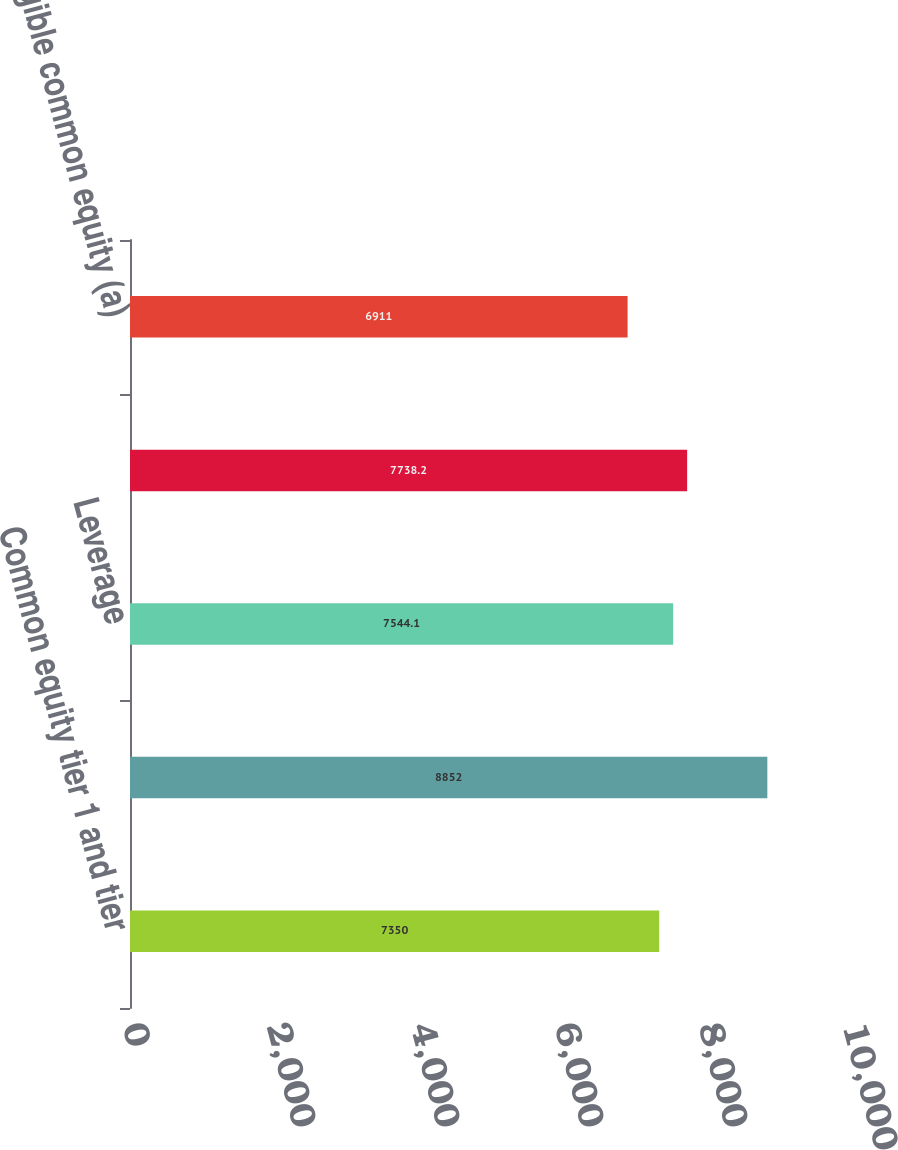Convert chart. <chart><loc_0><loc_0><loc_500><loc_500><bar_chart><fcel>Common equity tier 1 and tier<fcel>Total risk-based<fcel>Leverage<fcel>Common equity<fcel>Tangible common equity (a)<nl><fcel>7350<fcel>8852<fcel>7544.1<fcel>7738.2<fcel>6911<nl></chart> 